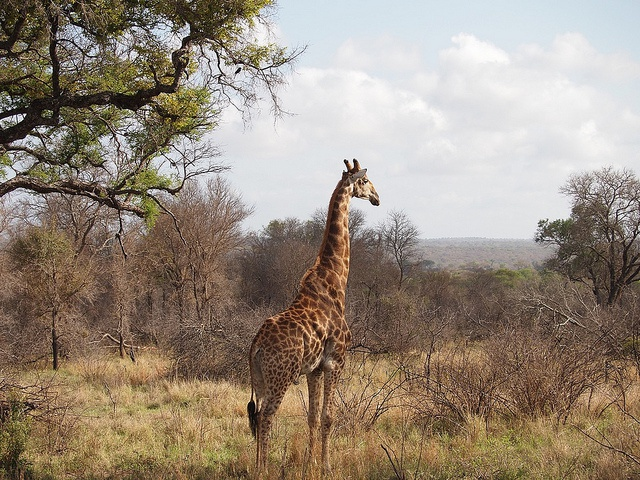Describe the objects in this image and their specific colors. I can see a giraffe in black, maroon, and gray tones in this image. 